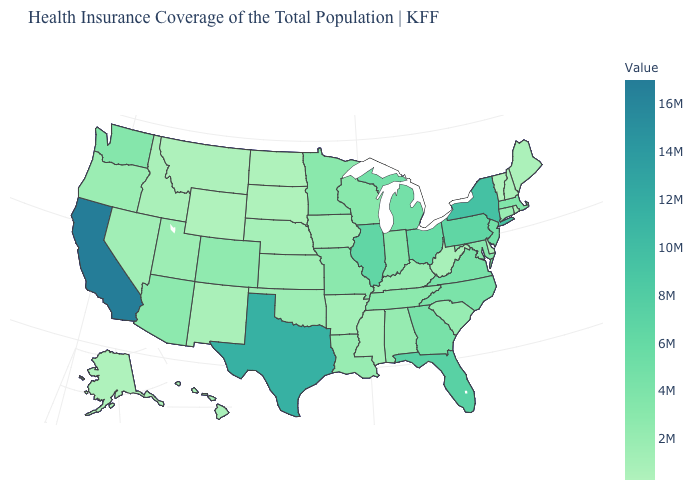Is the legend a continuous bar?
Quick response, please. Yes. Among the states that border Nebraska , which have the lowest value?
Give a very brief answer. Wyoming. Which states have the highest value in the USA?
Quick response, please. California. Does Vermont have the lowest value in the Northeast?
Write a very short answer. Yes. Does Vermont have the lowest value in the Northeast?
Short answer required. Yes. Among the states that border Georgia , which have the highest value?
Be succinct. Florida. Does Ohio have the lowest value in the USA?
Quick response, please. No. 